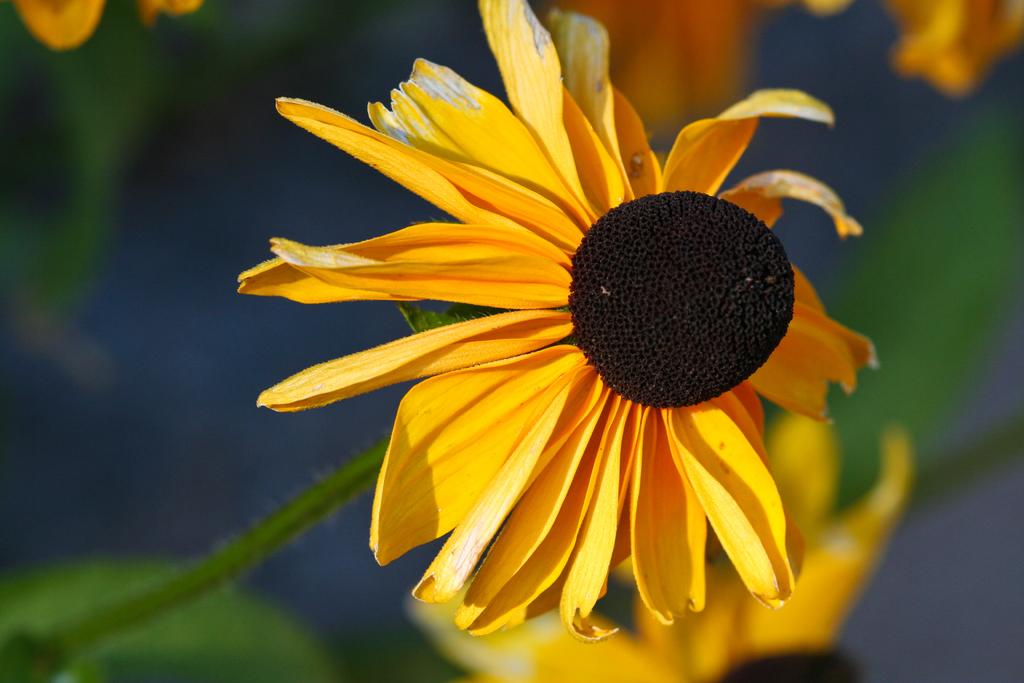What is located in the foreground of the image? There are flowers and leaves in the foreground of the image. Can you describe the appearance of the flowers? Unfortunately, the provided facts do not include a description of the flowers. What can be seen in the background of the image? The background of the image is not clear, so it is difficult to describe what is present. How does the cap help the flowers in the image? There is no mention of a cap in the image, so it cannot be determined how it might help the flowers. 